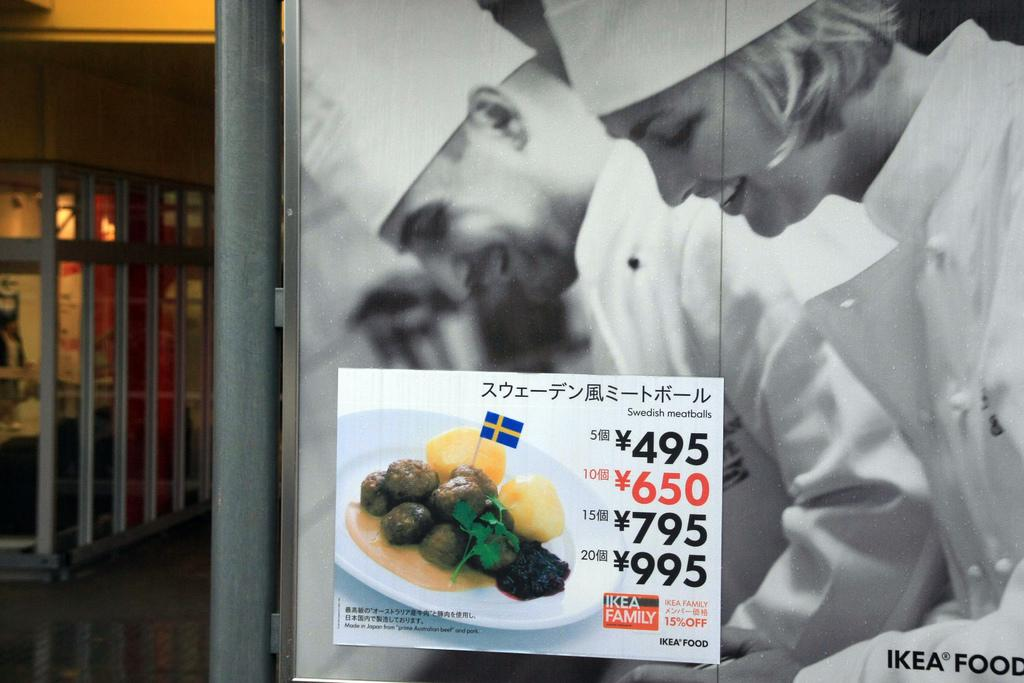What is present on the right side of the image? There is a banner on the right side of the image. What does the banner contain? The banner contains two people and food items. What type of crow can be seen flying near the banner in the image? There is no crow present in the image. What direction is the zephyr blowing the banner in the image? There is no mention of a zephyr or wind in the image, so it cannot be determined how the banner is positioned. 